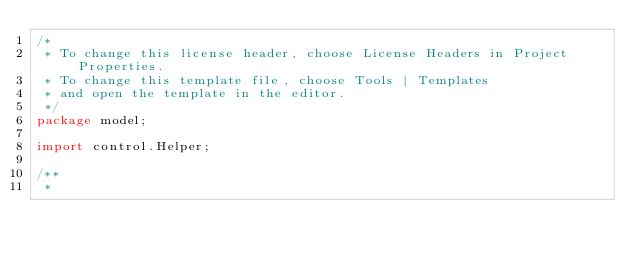Convert code to text. <code><loc_0><loc_0><loc_500><loc_500><_Java_>/*
 * To change this license header, choose License Headers in Project Properties.
 * To change this template file, choose Tools | Templates
 * and open the template in the editor.
 */
package model;

import control.Helper;

/**
 *</code> 